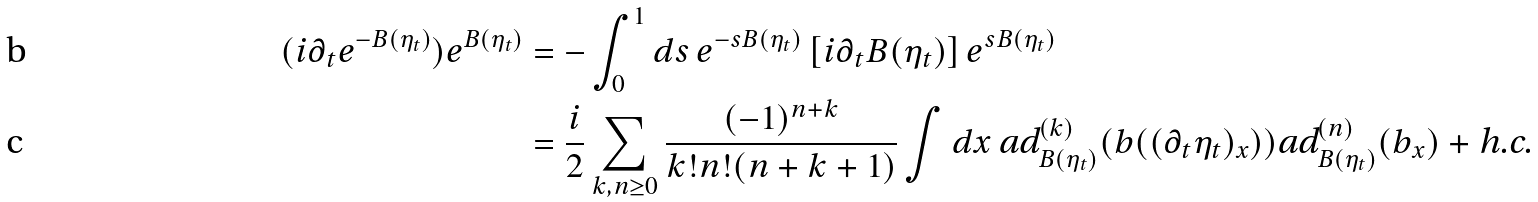<formula> <loc_0><loc_0><loc_500><loc_500>( i \partial _ { t } e ^ { - B ( \eta _ { t } ) } ) e ^ { B ( \eta _ { t } ) } & = - \int _ { 0 } ^ { 1 } d s \, e ^ { - s B ( \eta _ { t } ) } \left [ i \partial _ { t } B ( \eta _ { t } ) \right ] e ^ { s B ( \eta _ { t } ) } \\ & = \frac { i } { 2 } \sum _ { k , n \geq 0 } \frac { ( - 1 ) ^ { n + k } } { k ! n ! ( n + k + 1 ) } \int d x \, \text {ad} ^ { ( k ) } _ { B ( \eta _ { t } ) } ( b ( ( \partial _ { t } \eta _ { t } ) _ { x } ) ) \text {ad} ^ { ( n ) } _ { B ( \eta _ { t } ) } ( b _ { x } ) + \text {h.c.}</formula> 